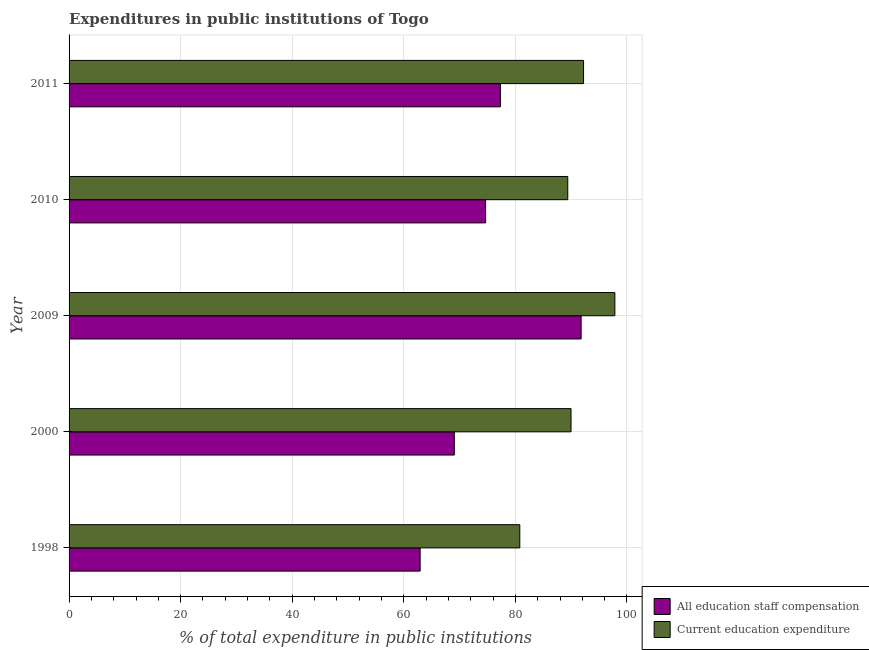How many groups of bars are there?
Make the answer very short. 5. Are the number of bars per tick equal to the number of legend labels?
Offer a terse response. Yes. Are the number of bars on each tick of the Y-axis equal?
Offer a terse response. Yes. In how many cases, is the number of bars for a given year not equal to the number of legend labels?
Your answer should be compact. 0. What is the expenditure in education in 2009?
Your response must be concise. 97.83. Across all years, what is the maximum expenditure in education?
Provide a succinct answer. 97.83. Across all years, what is the minimum expenditure in education?
Keep it short and to the point. 80.79. What is the total expenditure in education in the graph?
Offer a terse response. 450.21. What is the difference between the expenditure in staff compensation in 2000 and that in 2010?
Your response must be concise. -5.61. What is the difference between the expenditure in staff compensation in 2010 and the expenditure in education in 2000?
Provide a succinct answer. -15.31. What is the average expenditure in education per year?
Make the answer very short. 90.04. In the year 2010, what is the difference between the expenditure in staff compensation and expenditure in education?
Your answer should be compact. -14.73. In how many years, is the expenditure in staff compensation greater than 88 %?
Ensure brevity in your answer.  1. What is the ratio of the expenditure in staff compensation in 1998 to that in 2009?
Provide a short and direct response. 0.69. Is the expenditure in education in 2000 less than that in 2010?
Make the answer very short. No. What is the difference between the highest and the second highest expenditure in education?
Make the answer very short. 5.61. What is the difference between the highest and the lowest expenditure in education?
Offer a very short reply. 17.04. In how many years, is the expenditure in education greater than the average expenditure in education taken over all years?
Offer a terse response. 2. What does the 1st bar from the top in 2010 represents?
Provide a succinct answer. Current education expenditure. What does the 1st bar from the bottom in 1998 represents?
Provide a succinct answer. All education staff compensation. Are the values on the major ticks of X-axis written in scientific E-notation?
Ensure brevity in your answer.  No. Does the graph contain grids?
Make the answer very short. Yes. What is the title of the graph?
Keep it short and to the point. Expenditures in public institutions of Togo. Does "Frequency of shipment arrival" appear as one of the legend labels in the graph?
Ensure brevity in your answer.  No. What is the label or title of the X-axis?
Provide a succinct answer. % of total expenditure in public institutions. What is the label or title of the Y-axis?
Make the answer very short. Year. What is the % of total expenditure in public institutions of All education staff compensation in 1998?
Offer a terse response. 62.93. What is the % of total expenditure in public institutions in Current education expenditure in 1998?
Offer a very short reply. 80.79. What is the % of total expenditure in public institutions in All education staff compensation in 2000?
Provide a short and direct response. 69.05. What is the % of total expenditure in public institutions of Current education expenditure in 2000?
Offer a very short reply. 89.98. What is the % of total expenditure in public institutions in All education staff compensation in 2009?
Offer a very short reply. 91.79. What is the % of total expenditure in public institutions in Current education expenditure in 2009?
Make the answer very short. 97.83. What is the % of total expenditure in public institutions of All education staff compensation in 2010?
Give a very brief answer. 74.67. What is the % of total expenditure in public institutions in Current education expenditure in 2010?
Provide a short and direct response. 89.39. What is the % of total expenditure in public institutions of All education staff compensation in 2011?
Provide a short and direct response. 77.31. What is the % of total expenditure in public institutions in Current education expenditure in 2011?
Keep it short and to the point. 92.22. Across all years, what is the maximum % of total expenditure in public institutions in All education staff compensation?
Offer a very short reply. 91.79. Across all years, what is the maximum % of total expenditure in public institutions of Current education expenditure?
Offer a terse response. 97.83. Across all years, what is the minimum % of total expenditure in public institutions in All education staff compensation?
Give a very brief answer. 62.93. Across all years, what is the minimum % of total expenditure in public institutions in Current education expenditure?
Provide a succinct answer. 80.79. What is the total % of total expenditure in public institutions of All education staff compensation in the graph?
Give a very brief answer. 375.75. What is the total % of total expenditure in public institutions in Current education expenditure in the graph?
Provide a short and direct response. 450.21. What is the difference between the % of total expenditure in public institutions in All education staff compensation in 1998 and that in 2000?
Provide a succinct answer. -6.13. What is the difference between the % of total expenditure in public institutions of Current education expenditure in 1998 and that in 2000?
Your answer should be very brief. -9.18. What is the difference between the % of total expenditure in public institutions of All education staff compensation in 1998 and that in 2009?
Ensure brevity in your answer.  -28.86. What is the difference between the % of total expenditure in public institutions in Current education expenditure in 1998 and that in 2009?
Your response must be concise. -17.04. What is the difference between the % of total expenditure in public institutions in All education staff compensation in 1998 and that in 2010?
Your answer should be compact. -11.74. What is the difference between the % of total expenditure in public institutions in Current education expenditure in 1998 and that in 2010?
Give a very brief answer. -8.6. What is the difference between the % of total expenditure in public institutions in All education staff compensation in 1998 and that in 2011?
Ensure brevity in your answer.  -14.39. What is the difference between the % of total expenditure in public institutions in Current education expenditure in 1998 and that in 2011?
Provide a short and direct response. -11.43. What is the difference between the % of total expenditure in public institutions of All education staff compensation in 2000 and that in 2009?
Provide a succinct answer. -22.73. What is the difference between the % of total expenditure in public institutions in Current education expenditure in 2000 and that in 2009?
Give a very brief answer. -7.86. What is the difference between the % of total expenditure in public institutions in All education staff compensation in 2000 and that in 2010?
Give a very brief answer. -5.61. What is the difference between the % of total expenditure in public institutions of Current education expenditure in 2000 and that in 2010?
Offer a very short reply. 0.58. What is the difference between the % of total expenditure in public institutions of All education staff compensation in 2000 and that in 2011?
Your response must be concise. -8.26. What is the difference between the % of total expenditure in public institutions in Current education expenditure in 2000 and that in 2011?
Give a very brief answer. -2.25. What is the difference between the % of total expenditure in public institutions of All education staff compensation in 2009 and that in 2010?
Your answer should be very brief. 17.12. What is the difference between the % of total expenditure in public institutions in Current education expenditure in 2009 and that in 2010?
Provide a succinct answer. 8.44. What is the difference between the % of total expenditure in public institutions in All education staff compensation in 2009 and that in 2011?
Offer a very short reply. 14.47. What is the difference between the % of total expenditure in public institutions in Current education expenditure in 2009 and that in 2011?
Make the answer very short. 5.61. What is the difference between the % of total expenditure in public institutions of All education staff compensation in 2010 and that in 2011?
Provide a succinct answer. -2.65. What is the difference between the % of total expenditure in public institutions in Current education expenditure in 2010 and that in 2011?
Your answer should be compact. -2.83. What is the difference between the % of total expenditure in public institutions in All education staff compensation in 1998 and the % of total expenditure in public institutions in Current education expenditure in 2000?
Offer a very short reply. -27.05. What is the difference between the % of total expenditure in public institutions in All education staff compensation in 1998 and the % of total expenditure in public institutions in Current education expenditure in 2009?
Your answer should be compact. -34.9. What is the difference between the % of total expenditure in public institutions of All education staff compensation in 1998 and the % of total expenditure in public institutions of Current education expenditure in 2010?
Give a very brief answer. -26.46. What is the difference between the % of total expenditure in public institutions of All education staff compensation in 1998 and the % of total expenditure in public institutions of Current education expenditure in 2011?
Provide a short and direct response. -29.29. What is the difference between the % of total expenditure in public institutions in All education staff compensation in 2000 and the % of total expenditure in public institutions in Current education expenditure in 2009?
Provide a short and direct response. -28.78. What is the difference between the % of total expenditure in public institutions of All education staff compensation in 2000 and the % of total expenditure in public institutions of Current education expenditure in 2010?
Offer a very short reply. -20.34. What is the difference between the % of total expenditure in public institutions in All education staff compensation in 2000 and the % of total expenditure in public institutions in Current education expenditure in 2011?
Your answer should be compact. -23.17. What is the difference between the % of total expenditure in public institutions in All education staff compensation in 2009 and the % of total expenditure in public institutions in Current education expenditure in 2010?
Offer a very short reply. 2.39. What is the difference between the % of total expenditure in public institutions of All education staff compensation in 2009 and the % of total expenditure in public institutions of Current education expenditure in 2011?
Give a very brief answer. -0.44. What is the difference between the % of total expenditure in public institutions in All education staff compensation in 2010 and the % of total expenditure in public institutions in Current education expenditure in 2011?
Make the answer very short. -17.56. What is the average % of total expenditure in public institutions in All education staff compensation per year?
Make the answer very short. 75.15. What is the average % of total expenditure in public institutions of Current education expenditure per year?
Give a very brief answer. 90.04. In the year 1998, what is the difference between the % of total expenditure in public institutions of All education staff compensation and % of total expenditure in public institutions of Current education expenditure?
Provide a succinct answer. -17.87. In the year 2000, what is the difference between the % of total expenditure in public institutions in All education staff compensation and % of total expenditure in public institutions in Current education expenditure?
Make the answer very short. -20.92. In the year 2009, what is the difference between the % of total expenditure in public institutions in All education staff compensation and % of total expenditure in public institutions in Current education expenditure?
Provide a short and direct response. -6.05. In the year 2010, what is the difference between the % of total expenditure in public institutions of All education staff compensation and % of total expenditure in public institutions of Current education expenditure?
Your answer should be very brief. -14.73. In the year 2011, what is the difference between the % of total expenditure in public institutions of All education staff compensation and % of total expenditure in public institutions of Current education expenditure?
Offer a terse response. -14.91. What is the ratio of the % of total expenditure in public institutions of All education staff compensation in 1998 to that in 2000?
Ensure brevity in your answer.  0.91. What is the ratio of the % of total expenditure in public institutions in Current education expenditure in 1998 to that in 2000?
Your answer should be compact. 0.9. What is the ratio of the % of total expenditure in public institutions in All education staff compensation in 1998 to that in 2009?
Provide a succinct answer. 0.69. What is the ratio of the % of total expenditure in public institutions of Current education expenditure in 1998 to that in 2009?
Offer a terse response. 0.83. What is the ratio of the % of total expenditure in public institutions in All education staff compensation in 1998 to that in 2010?
Keep it short and to the point. 0.84. What is the ratio of the % of total expenditure in public institutions in Current education expenditure in 1998 to that in 2010?
Give a very brief answer. 0.9. What is the ratio of the % of total expenditure in public institutions of All education staff compensation in 1998 to that in 2011?
Give a very brief answer. 0.81. What is the ratio of the % of total expenditure in public institutions of Current education expenditure in 1998 to that in 2011?
Ensure brevity in your answer.  0.88. What is the ratio of the % of total expenditure in public institutions in All education staff compensation in 2000 to that in 2009?
Offer a very short reply. 0.75. What is the ratio of the % of total expenditure in public institutions in Current education expenditure in 2000 to that in 2009?
Your answer should be very brief. 0.92. What is the ratio of the % of total expenditure in public institutions of All education staff compensation in 2000 to that in 2010?
Offer a terse response. 0.92. What is the ratio of the % of total expenditure in public institutions in Current education expenditure in 2000 to that in 2010?
Your answer should be compact. 1.01. What is the ratio of the % of total expenditure in public institutions in All education staff compensation in 2000 to that in 2011?
Your answer should be compact. 0.89. What is the ratio of the % of total expenditure in public institutions of Current education expenditure in 2000 to that in 2011?
Give a very brief answer. 0.98. What is the ratio of the % of total expenditure in public institutions of All education staff compensation in 2009 to that in 2010?
Provide a short and direct response. 1.23. What is the ratio of the % of total expenditure in public institutions in Current education expenditure in 2009 to that in 2010?
Make the answer very short. 1.09. What is the ratio of the % of total expenditure in public institutions in All education staff compensation in 2009 to that in 2011?
Keep it short and to the point. 1.19. What is the ratio of the % of total expenditure in public institutions in Current education expenditure in 2009 to that in 2011?
Ensure brevity in your answer.  1.06. What is the ratio of the % of total expenditure in public institutions in All education staff compensation in 2010 to that in 2011?
Give a very brief answer. 0.97. What is the ratio of the % of total expenditure in public institutions in Current education expenditure in 2010 to that in 2011?
Your response must be concise. 0.97. What is the difference between the highest and the second highest % of total expenditure in public institutions of All education staff compensation?
Make the answer very short. 14.47. What is the difference between the highest and the second highest % of total expenditure in public institutions of Current education expenditure?
Your response must be concise. 5.61. What is the difference between the highest and the lowest % of total expenditure in public institutions in All education staff compensation?
Provide a succinct answer. 28.86. What is the difference between the highest and the lowest % of total expenditure in public institutions in Current education expenditure?
Make the answer very short. 17.04. 